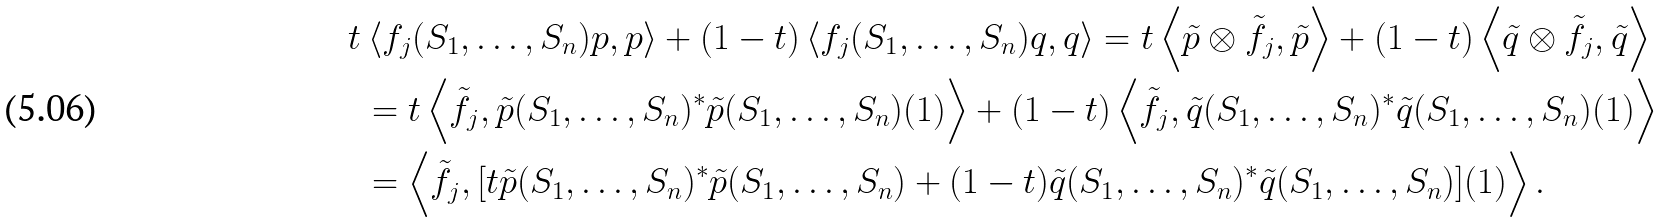<formula> <loc_0><loc_0><loc_500><loc_500>t & \left < f _ { j } ( S _ { 1 } , \dots , S _ { n } ) p , p \right > + ( 1 - t ) \left < f _ { j } ( S _ { 1 } , \dots , S _ { n } ) q , q \right > = t \left < \tilde { p } \otimes \tilde { f _ { j } } , \tilde { p } \right > + ( 1 - t ) \left < \tilde { q } \otimes \tilde { f _ { j } } , \tilde { q } \right > \\ & = t \left < \tilde { f _ { j } } , \tilde { p } ( S _ { 1 } , \dots , S _ { n } ) ^ { * } \tilde { p } ( S _ { 1 } , \dots , S _ { n } ) ( 1 ) \right > + ( 1 - t ) \left < \tilde { f _ { j } } , \tilde { q } ( S _ { 1 } , \dots , S _ { n } ) ^ { * } \tilde { q } ( S _ { 1 } , \dots , S _ { n } ) ( 1 ) \right > \\ & = \left < \tilde { f _ { j } } , [ t \tilde { p } ( S _ { 1 } , \dots , S _ { n } ) ^ { * } \tilde { p } ( S _ { 1 } , \dots , S _ { n } ) + ( 1 - t ) \tilde { q } ( S _ { 1 } , \dots , S _ { n } ) ^ { * } \tilde { q } ( S _ { 1 } , \dots , S _ { n } ) ] ( 1 ) \right > .</formula> 